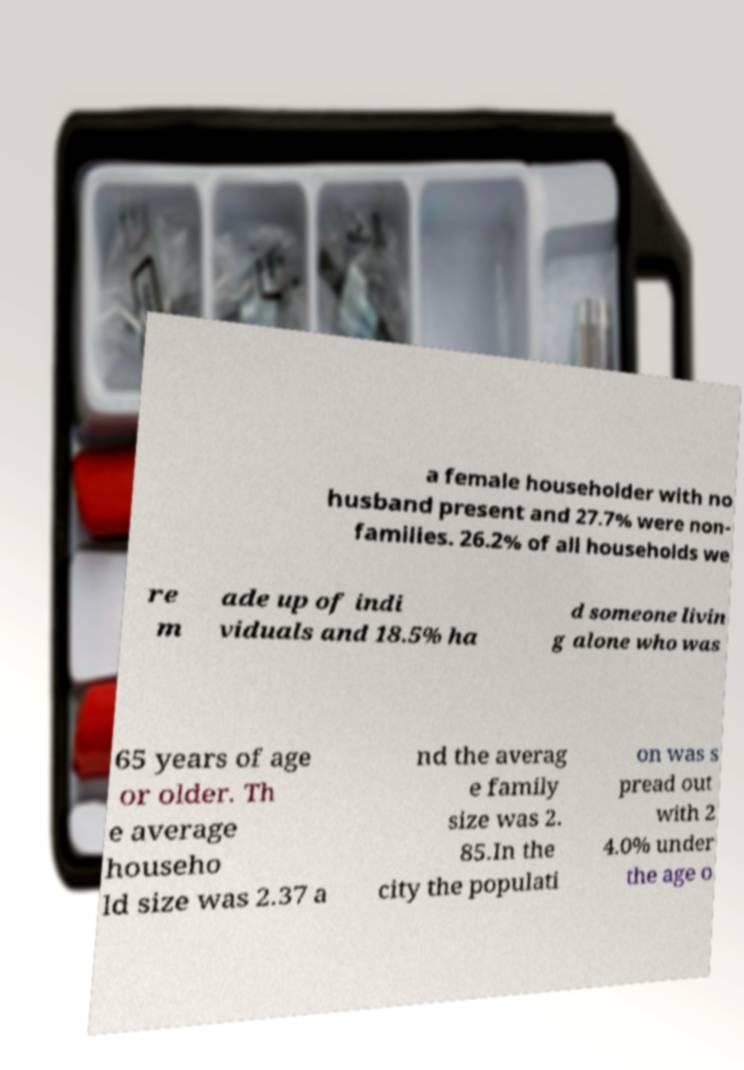Please read and relay the text visible in this image. What does it say? a female householder with no husband present and 27.7% were non- families. 26.2% of all households we re m ade up of indi viduals and 18.5% ha d someone livin g alone who was 65 years of age or older. Th e average househo ld size was 2.37 a nd the averag e family size was 2. 85.In the city the populati on was s pread out with 2 4.0% under the age o 